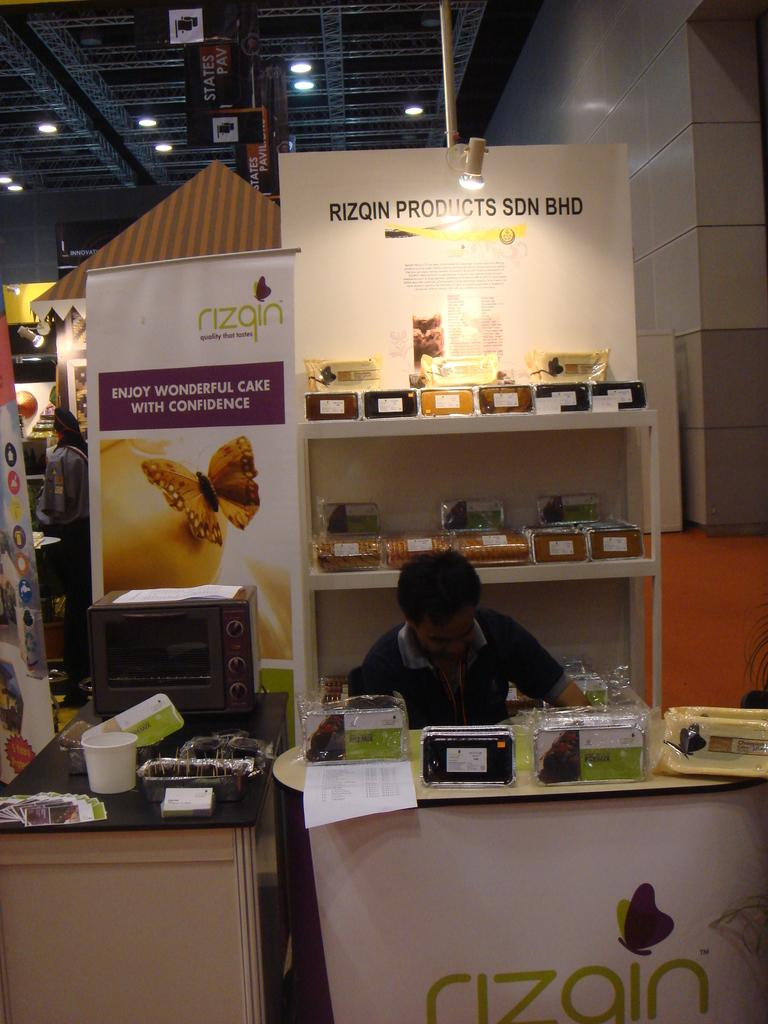<image>
Create a compact narrative representing the image presented. a store display of Rizqin Products SDN BHD 